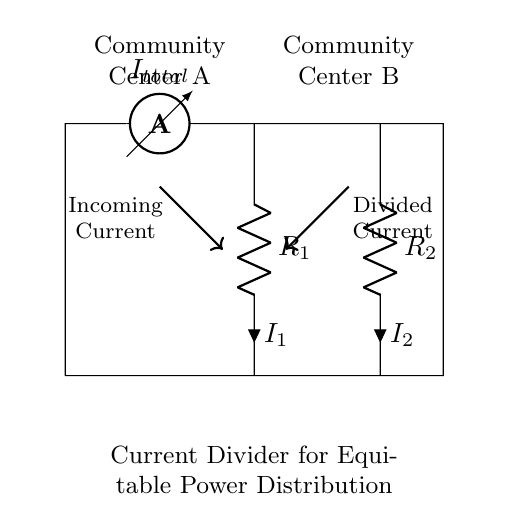What is the total current entering the circuit? The total current entering the circuit is denoted by the ammeter labeled "I total" located at the top of the circuit.
Answer: I total What are the resistors in the circuit? The circuit includes two resistors labeled "R 1" and "R 2," which are connected in parallel and are responsible for dividing the current.
Answer: R 1 and R 2 What does the current divider achieve in this circuit? The current divider allows the total current to be split into two separate paths for equitable power distribution to Community Center A and Community Center B.
Answer: Equitable power distribution How would you calculate the current through R 1? To find the current through R 1, you would apply the current divider rule, which states that I 1 equals the total current multiplied by the ratio of the resistance R 2 to the total resistance (R 1 + R 2).
Answer: I 1 = I total * (R 2 / (R 1 + R 2)) What is the significance of the arrows in the circuit diagram? The arrows in the diagram indicate the direction of current flow and help to visualize how current travels through the circuit from the ammeter to the resistors.
Answer: Direction of current flow If R 1 is twice the value of R 2, how does this affect the current distribution? If R 1 is twice the value of R 2, the current through R 1 would be less than through R 2 according to the current divider principle, leading to an uneven current distribution favoring R 2.
Answer: Unequal current distribution favoring R 2 